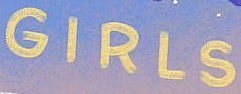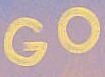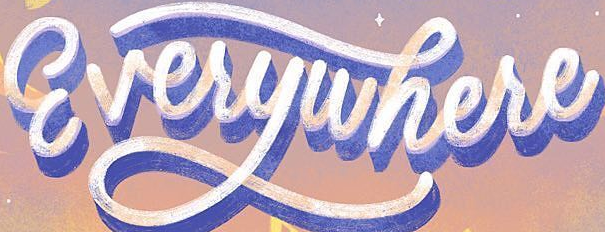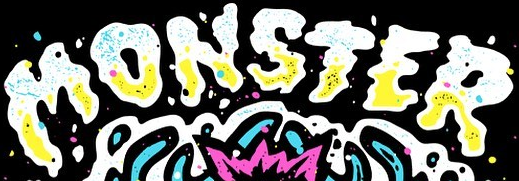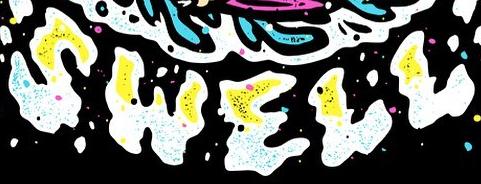Identify the words shown in these images in order, separated by a semicolon. GIRLS; GO; Everywhere; MONSTER; SWELL 